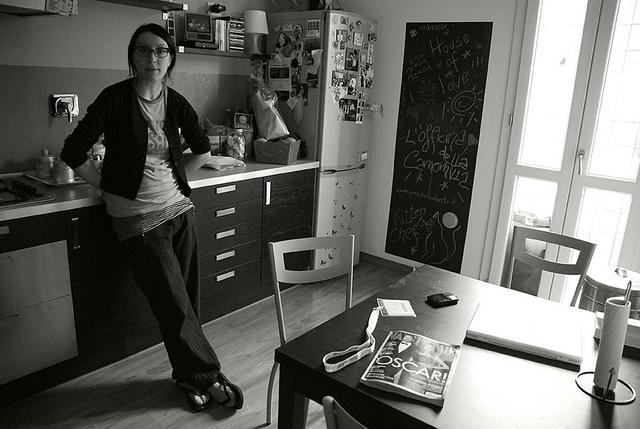Excellence in the American and International film industry award is what?

Choices:
A) cambridge
B) oscar
C) national
D) oxford oscar 